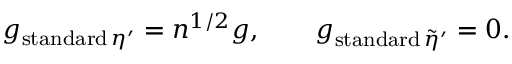Convert formula to latex. <formula><loc_0><loc_0><loc_500><loc_500>g _ { s t a n d a r d \, \eta ^ { \prime } } = n ^ { 1 / 2 } g , \quad g _ { s t a n d a r d \, \tilde { \eta } ^ { \prime } } = 0 .</formula> 